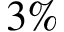<formula> <loc_0><loc_0><loc_500><loc_500>3 \%</formula> 